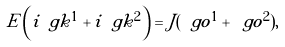Convert formula to latex. <formula><loc_0><loc_0><loc_500><loc_500>E \left ( i \ g k ^ { 1 } + i \ g k ^ { 2 } \right ) = J ( \ g o ^ { 1 } + \ g o ^ { 2 } ) ,</formula> 